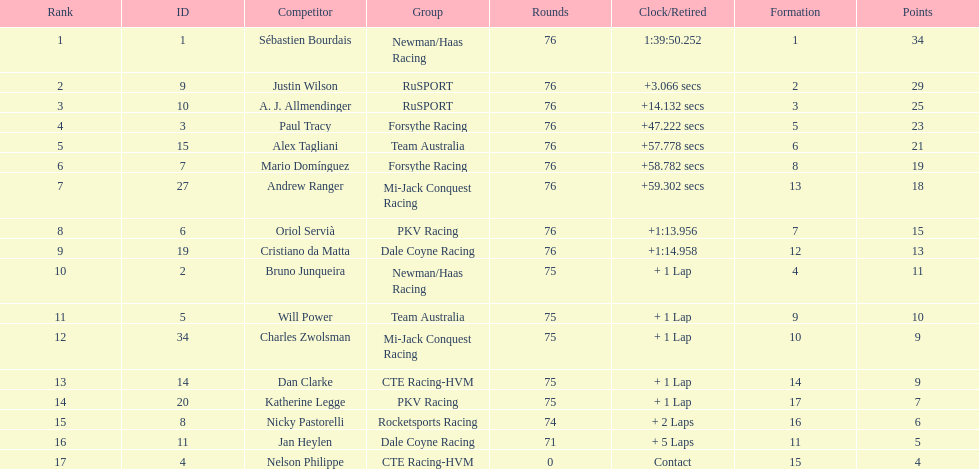Who drove during the 2006 tecate grand prix of monterrey? Sébastien Bourdais, Justin Wilson, A. J. Allmendinger, Paul Tracy, Alex Tagliani, Mario Domínguez, Andrew Ranger, Oriol Servià, Cristiano da Matta, Bruno Junqueira, Will Power, Charles Zwolsman, Dan Clarke, Katherine Legge, Nicky Pastorelli, Jan Heylen, Nelson Philippe. And what were their finishing positions? 1, 2, 3, 4, 5, 6, 7, 8, 9, 10, 11, 12, 13, 14, 15, 16, 17. Who did alex tagliani finish directly behind of? Paul Tracy. Help me parse the entirety of this table. {'header': ['Rank', 'ID', 'Competitor', 'Group', 'Rounds', 'Clock/Retired', 'Formation', 'Points'], 'rows': [['1', '1', 'Sébastien Bourdais', 'Newman/Haas Racing', '76', '1:39:50.252', '1', '34'], ['2', '9', 'Justin Wilson', 'RuSPORT', '76', '+3.066 secs', '2', '29'], ['3', '10', 'A. J. Allmendinger', 'RuSPORT', '76', '+14.132 secs', '3', '25'], ['4', '3', 'Paul Tracy', 'Forsythe Racing', '76', '+47.222 secs', '5', '23'], ['5', '15', 'Alex Tagliani', 'Team Australia', '76', '+57.778 secs', '6', '21'], ['6', '7', 'Mario Domínguez', 'Forsythe Racing', '76', '+58.782 secs', '8', '19'], ['7', '27', 'Andrew Ranger', 'Mi-Jack Conquest Racing', '76', '+59.302 secs', '13', '18'], ['8', '6', 'Oriol Servià', 'PKV Racing', '76', '+1:13.956', '7', '15'], ['9', '19', 'Cristiano da Matta', 'Dale Coyne Racing', '76', '+1:14.958', '12', '13'], ['10', '2', 'Bruno Junqueira', 'Newman/Haas Racing', '75', '+ 1 Lap', '4', '11'], ['11', '5', 'Will Power', 'Team Australia', '75', '+ 1 Lap', '9', '10'], ['12', '34', 'Charles Zwolsman', 'Mi-Jack Conquest Racing', '75', '+ 1 Lap', '10', '9'], ['13', '14', 'Dan Clarke', 'CTE Racing-HVM', '75', '+ 1 Lap', '14', '9'], ['14', '20', 'Katherine Legge', 'PKV Racing', '75', '+ 1 Lap', '17', '7'], ['15', '8', 'Nicky Pastorelli', 'Rocketsports Racing', '74', '+ 2 Laps', '16', '6'], ['16', '11', 'Jan Heylen', 'Dale Coyne Racing', '71', '+ 5 Laps', '11', '5'], ['17', '4', 'Nelson Philippe', 'CTE Racing-HVM', '0', 'Contact', '15', '4']]} 